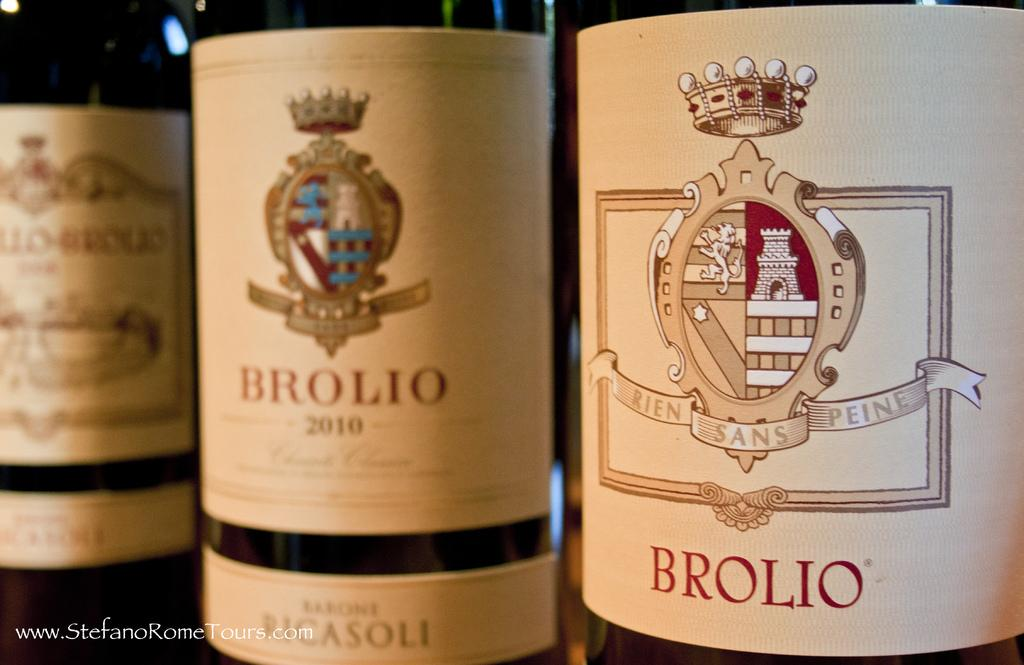<image>
Relay a brief, clear account of the picture shown. three bottles of Brolio wine with different coats of arms. 